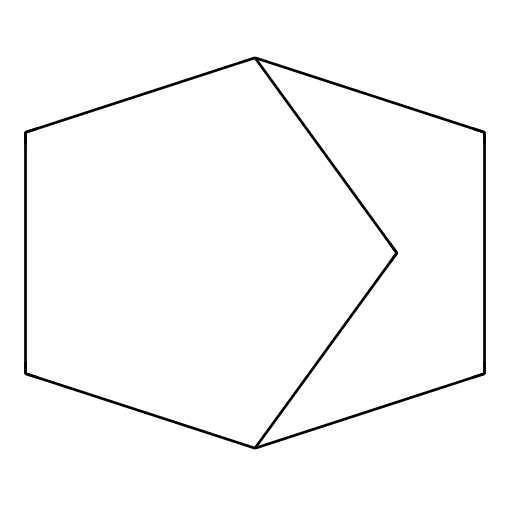What is the molecular formula of norbornane? The SMILES representation can be interpreted to identify the number of carbon and hydrogen atoms present. Counting the carbon atoms in the structure, there are 10 carbon atoms (C), and by using the general formula for saturated hydrocarbons (C_nH_(2n)), we can confirm there are 18 hydrogen atoms (H). Therefore, the molecular formula is C10H18.
Answer: C10H18 How many rings are present in norbornane? Analyzing the structure as depicted in the SMILES, norbornane exhibits a cyclic structure with two fused rings (the two parts where the cyclic portions meet), indicating a total of 2 rings.
Answer: 2 What is the primary characteristic of norbornane? The significance of norbornane in chemical structures lies in its unique bridging framework of cycloalkanes which gives it distinct chemical properties, making it a bridged bicyclic compound.
Answer: bridged bicyclic compound Is norbornane a saturated or unsaturated hydrocarbon? The presence of only single bonds in the SMILES depiction indicates that norbornane is a saturated hydrocarbon, which defines it as one containing the maximum number of hydrogen atoms per carbon.
Answer: saturated How many carbon-carbon bonds are present? By analyzing the structure from the SMILES notation and counting the distinct connections between carbon atoms, we identify that norbornane contains 9 carbon-carbon bonds.
Answer: 9 What type of isomerism can norbornane exhibit? The structural configuration allows for the existence of stereoisomers due to the specific arrangement of atoms, particularly around the fused rings, leading to the possibility of different spatial arrangements that qualify as stereoisomerism.
Answer: stereoisomerism 